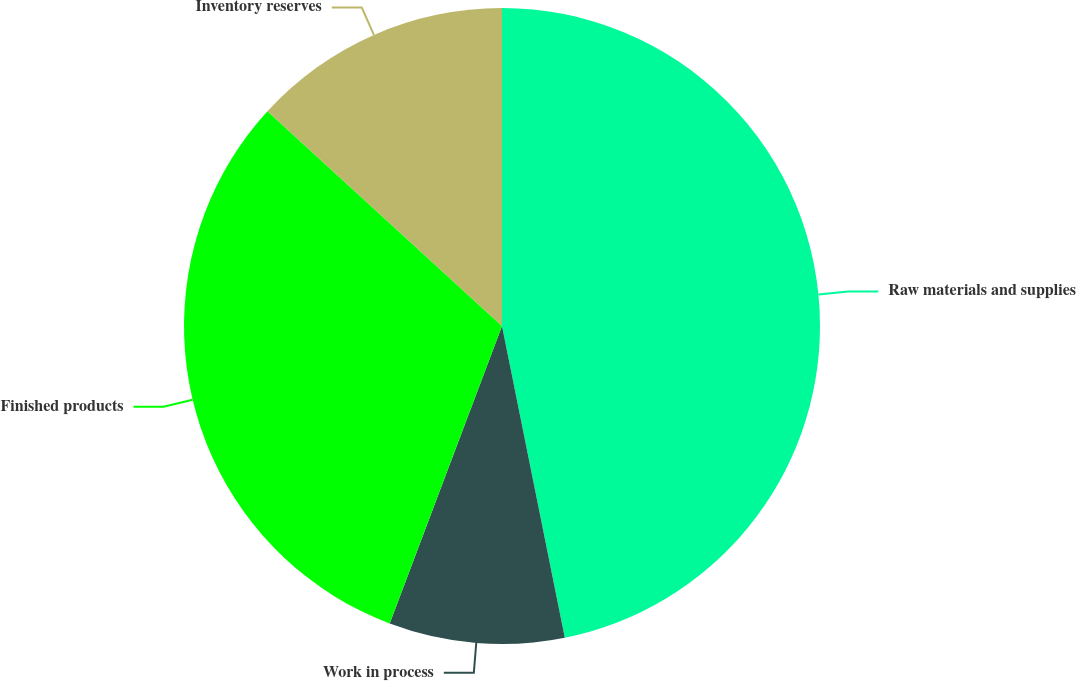Convert chart. <chart><loc_0><loc_0><loc_500><loc_500><pie_chart><fcel>Raw materials and supplies<fcel>Work in process<fcel>Finished products<fcel>Inventory reserves<nl><fcel>46.84%<fcel>8.91%<fcel>31.06%<fcel>13.2%<nl></chart> 